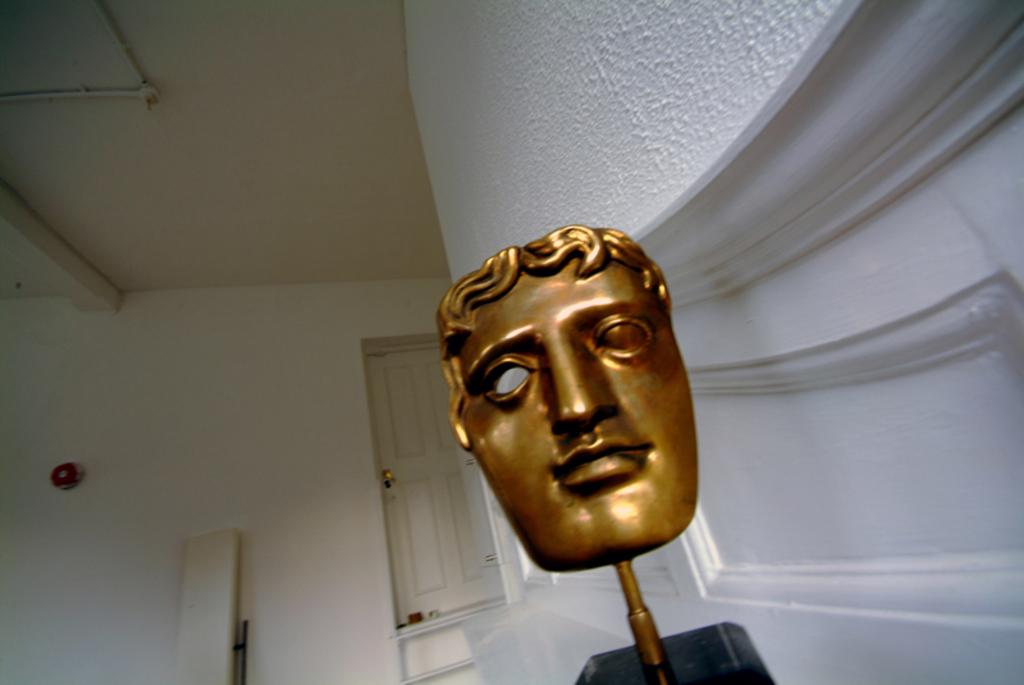What object is the main focus of the image? There is a face mask in the image. What is behind the face mask in the image? There is a wall behind the face mask. What architectural feature is located beside the wall in the image? There is a door beside the wall in the image. What type of locket is hanging from the face mask in the image? There is no locket present in the image; it only features a face mask, a wall, and a door. 